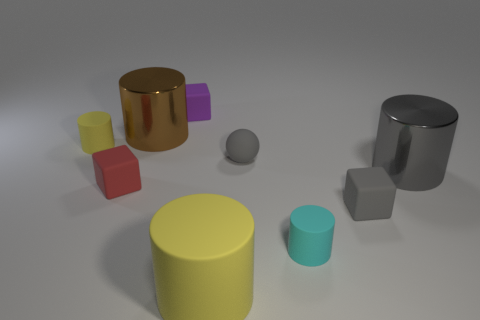Do the small ball and the big object right of the cyan thing have the same color?
Offer a very short reply. Yes. Is there any other thing that has the same color as the large matte cylinder?
Offer a very short reply. Yes. The other rubber object that is the same color as the large rubber thing is what shape?
Make the answer very short. Cylinder. Is the color of the cube in front of the red object the same as the matte ball?
Make the answer very short. Yes. Are there any rubber cylinders of the same color as the big rubber object?
Provide a short and direct response. Yes. Are there any other things that have the same shape as the brown metal thing?
Ensure brevity in your answer.  Yes. The other large metallic thing that is the same shape as the large gray metal thing is what color?
Your answer should be very brief. Brown. What is the size of the gray metallic object?
Give a very brief answer. Large. Is the number of gray spheres that are to the left of the small purple thing less than the number of big matte cylinders?
Offer a terse response. Yes. Is the material of the large gray object the same as the yellow cylinder in front of the tiny red rubber thing?
Your answer should be very brief. No. 